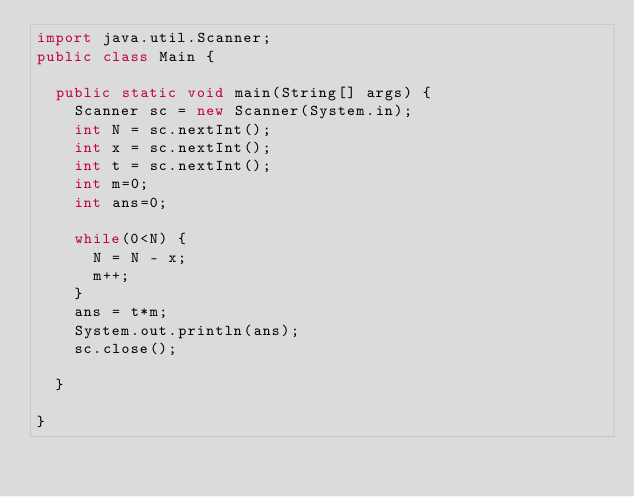Convert code to text. <code><loc_0><loc_0><loc_500><loc_500><_Java_>import java.util.Scanner;
public class Main {

	public static void main(String[] args) {
		Scanner sc = new Scanner(System.in);
		int N = sc.nextInt();
		int x = sc.nextInt();
		int t = sc.nextInt();
		int m=0;
		int ans=0;
		
		while(0<N) {
			N = N - x;
			m++;
		}
		ans = t*m;
		System.out.println(ans);
		sc.close();
		
	}

}
</code> 